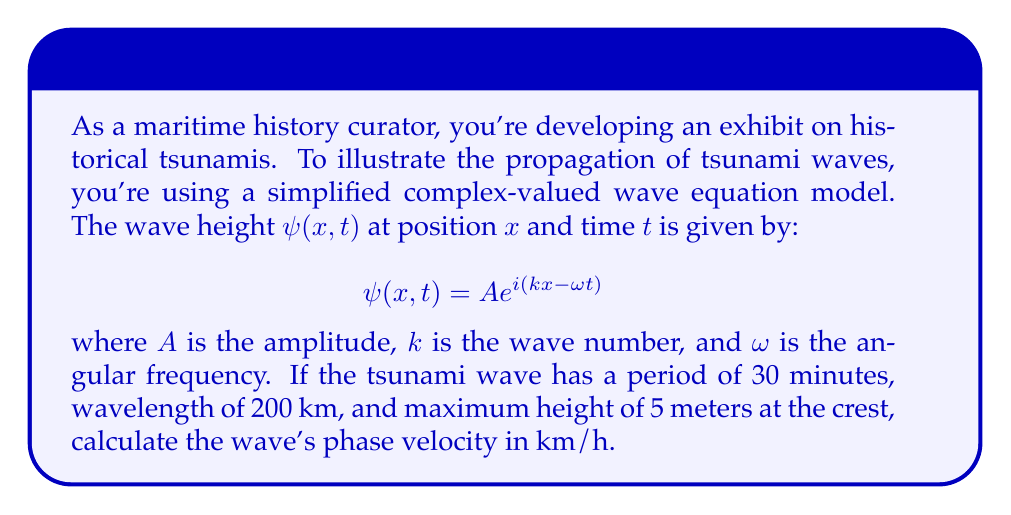Solve this math problem. Let's approach this step-by-step:

1) First, we need to understand the given information:
   - Period $T = 30$ minutes = 0.5 hours
   - Wavelength $\lambda = 200$ km
   - Amplitude $A = 5$ meters (half the crest-to-trough height)

2) We know that angular frequency $\omega$ is related to period $T$ by:
   $$\omega = \frac{2\pi}{T}$$

3) The wave number $k$ is related to wavelength $\lambda$ by:
   $$k = \frac{2\pi}{\lambda}$$

4) The phase velocity $v$ is given by:
   $$v = \frac{\omega}{k}$$

5) Substituting the expressions for $\omega$ and $k$:
   $$v = \frac{2\pi/T}{2\pi/\lambda} = \frac{\lambda}{T}$$

6) Now we can plug in our values:
   $$v = \frac{200 \text{ km}}{0.5 \text{ h}} = 400 \text{ km/h}$$

Thus, the tsunami wave's phase velocity is 400 km/h.
Answer: 400 km/h 